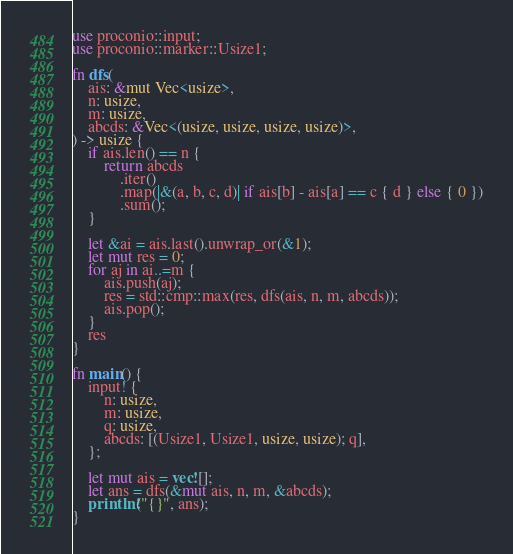Convert code to text. <code><loc_0><loc_0><loc_500><loc_500><_Rust_>use proconio::input;
use proconio::marker::Usize1;

fn dfs(
    ais: &mut Vec<usize>,
    n: usize,
    m: usize,
    abcds: &Vec<(usize, usize, usize, usize)>,
) -> usize {
    if ais.len() == n {
        return abcds
            .iter()
            .map(|&(a, b, c, d)| if ais[b] - ais[a] == c { d } else { 0 })
            .sum();
    }

    let &ai = ais.last().unwrap_or(&1);
    let mut res = 0;
    for aj in ai..=m {
        ais.push(aj);
        res = std::cmp::max(res, dfs(ais, n, m, abcds));
        ais.pop();
    }
    res
}

fn main() {
    input! {
        n: usize,
        m: usize,
        q: usize,
        abcds: [(Usize1, Usize1, usize, usize); q],
    };

    let mut ais = vec![];
    let ans = dfs(&mut ais, n, m, &abcds);
    println!("{}", ans);
}
</code> 